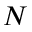Convert formula to latex. <formula><loc_0><loc_0><loc_500><loc_500>N</formula> 